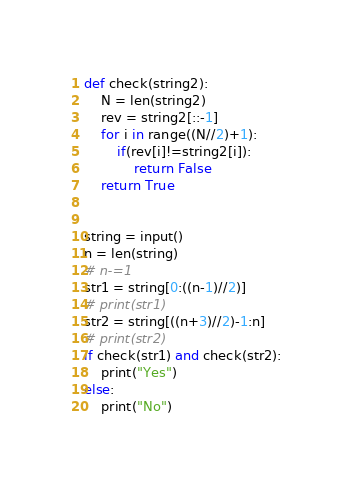<code> <loc_0><loc_0><loc_500><loc_500><_Python_>def check(string2):
	N = len(string2)
	rev = string2[::-1]
	for i in range((N//2)+1):
		if(rev[i]!=string2[i]):
			return False
	return True


string = input()
n = len(string)
# n-=1
str1 = string[0:((n-1)//2)]
# print(str1)
str2 = string[((n+3)//2)-1:n]
# print(str2)
if check(str1) and check(str2):
	print("Yes")
else:
	print("No")</code> 